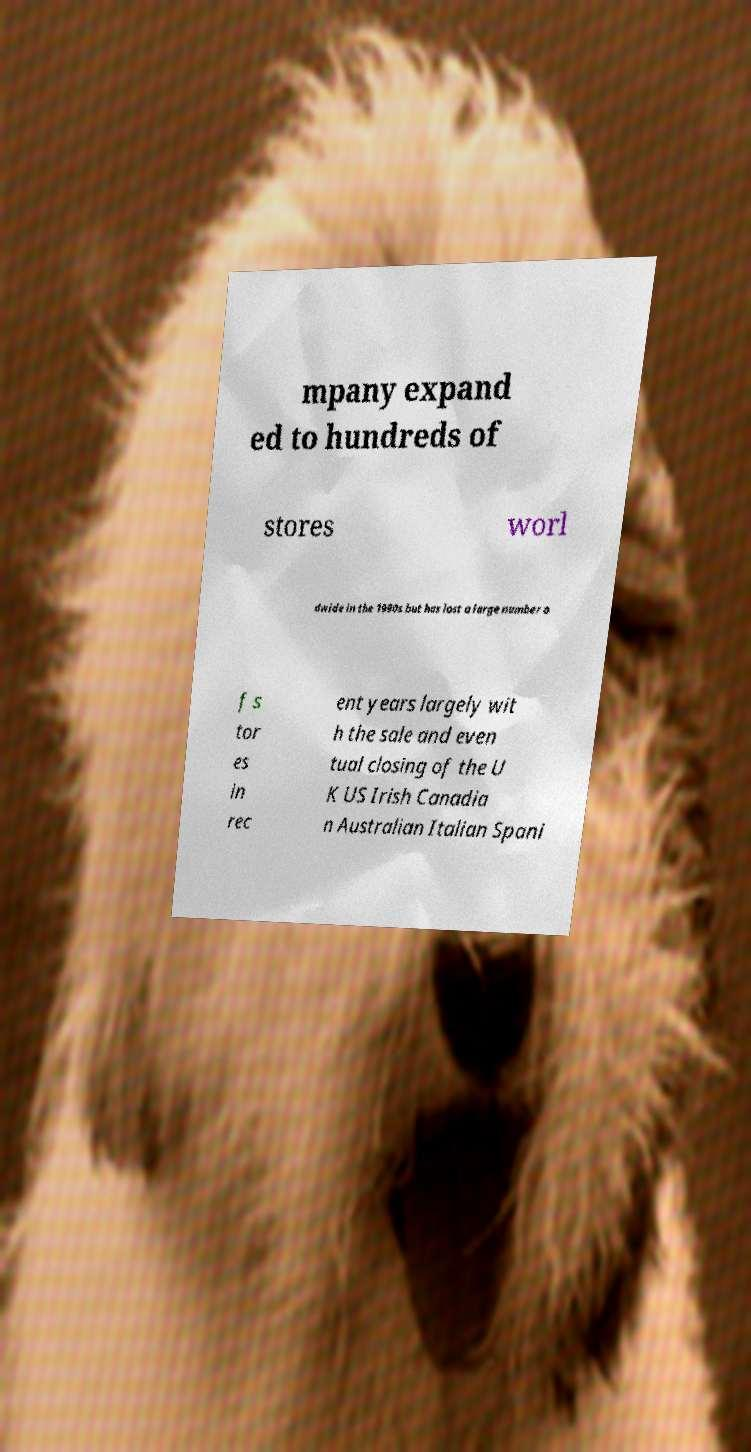Please read and relay the text visible in this image. What does it say? mpany expand ed to hundreds of stores worl dwide in the 1990s but has lost a large number o f s tor es in rec ent years largely wit h the sale and even tual closing of the U K US Irish Canadia n Australian Italian Spani 